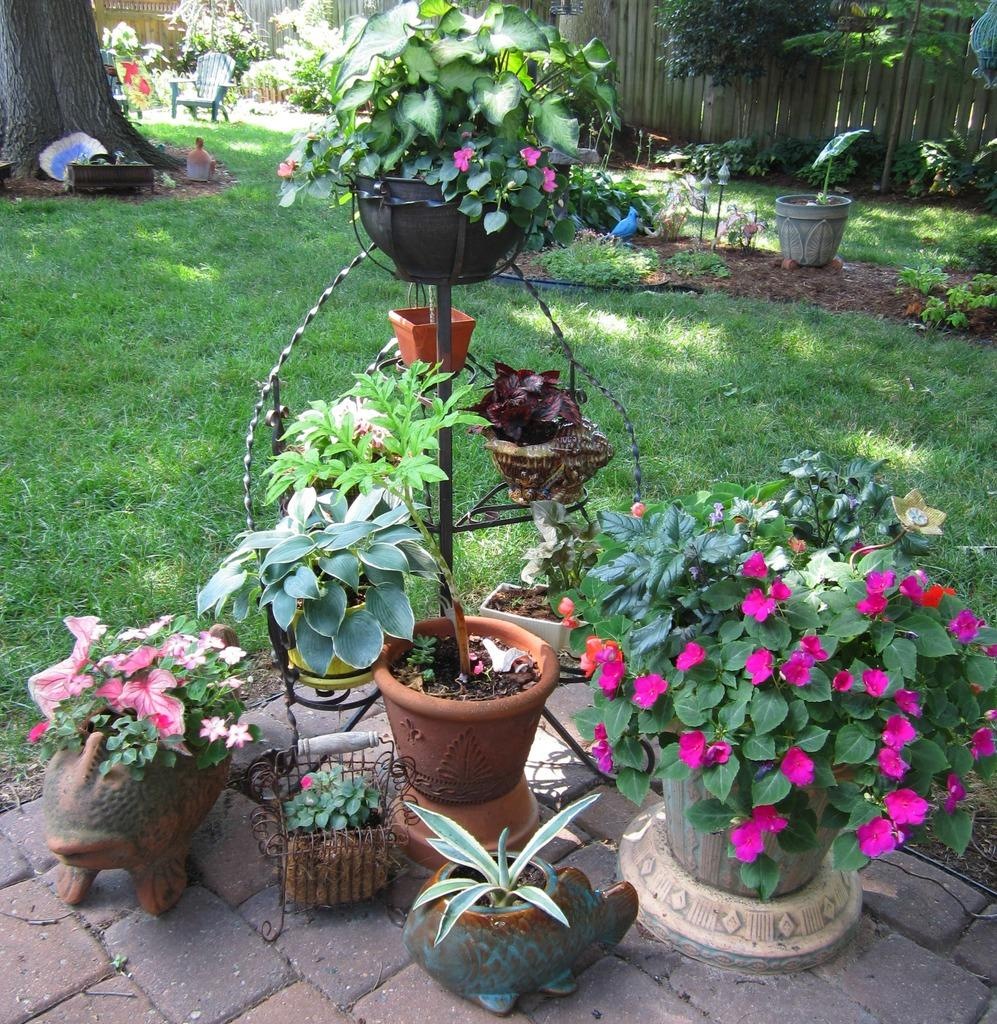What type of vegetation can be seen in the image? There is grass, plants, and flowers in the image. What is the main feature of the tree in the image? There is a tree trunk in the image. What else can be seen in the image besides vegetation? There are other objects in the image. What is visible in the background of the image? There is a fence in the background of the image. How does the police officer help the flowers grow in the image? There is no police officer present in the image, and therefore no assistance can be provided to the flowers. 